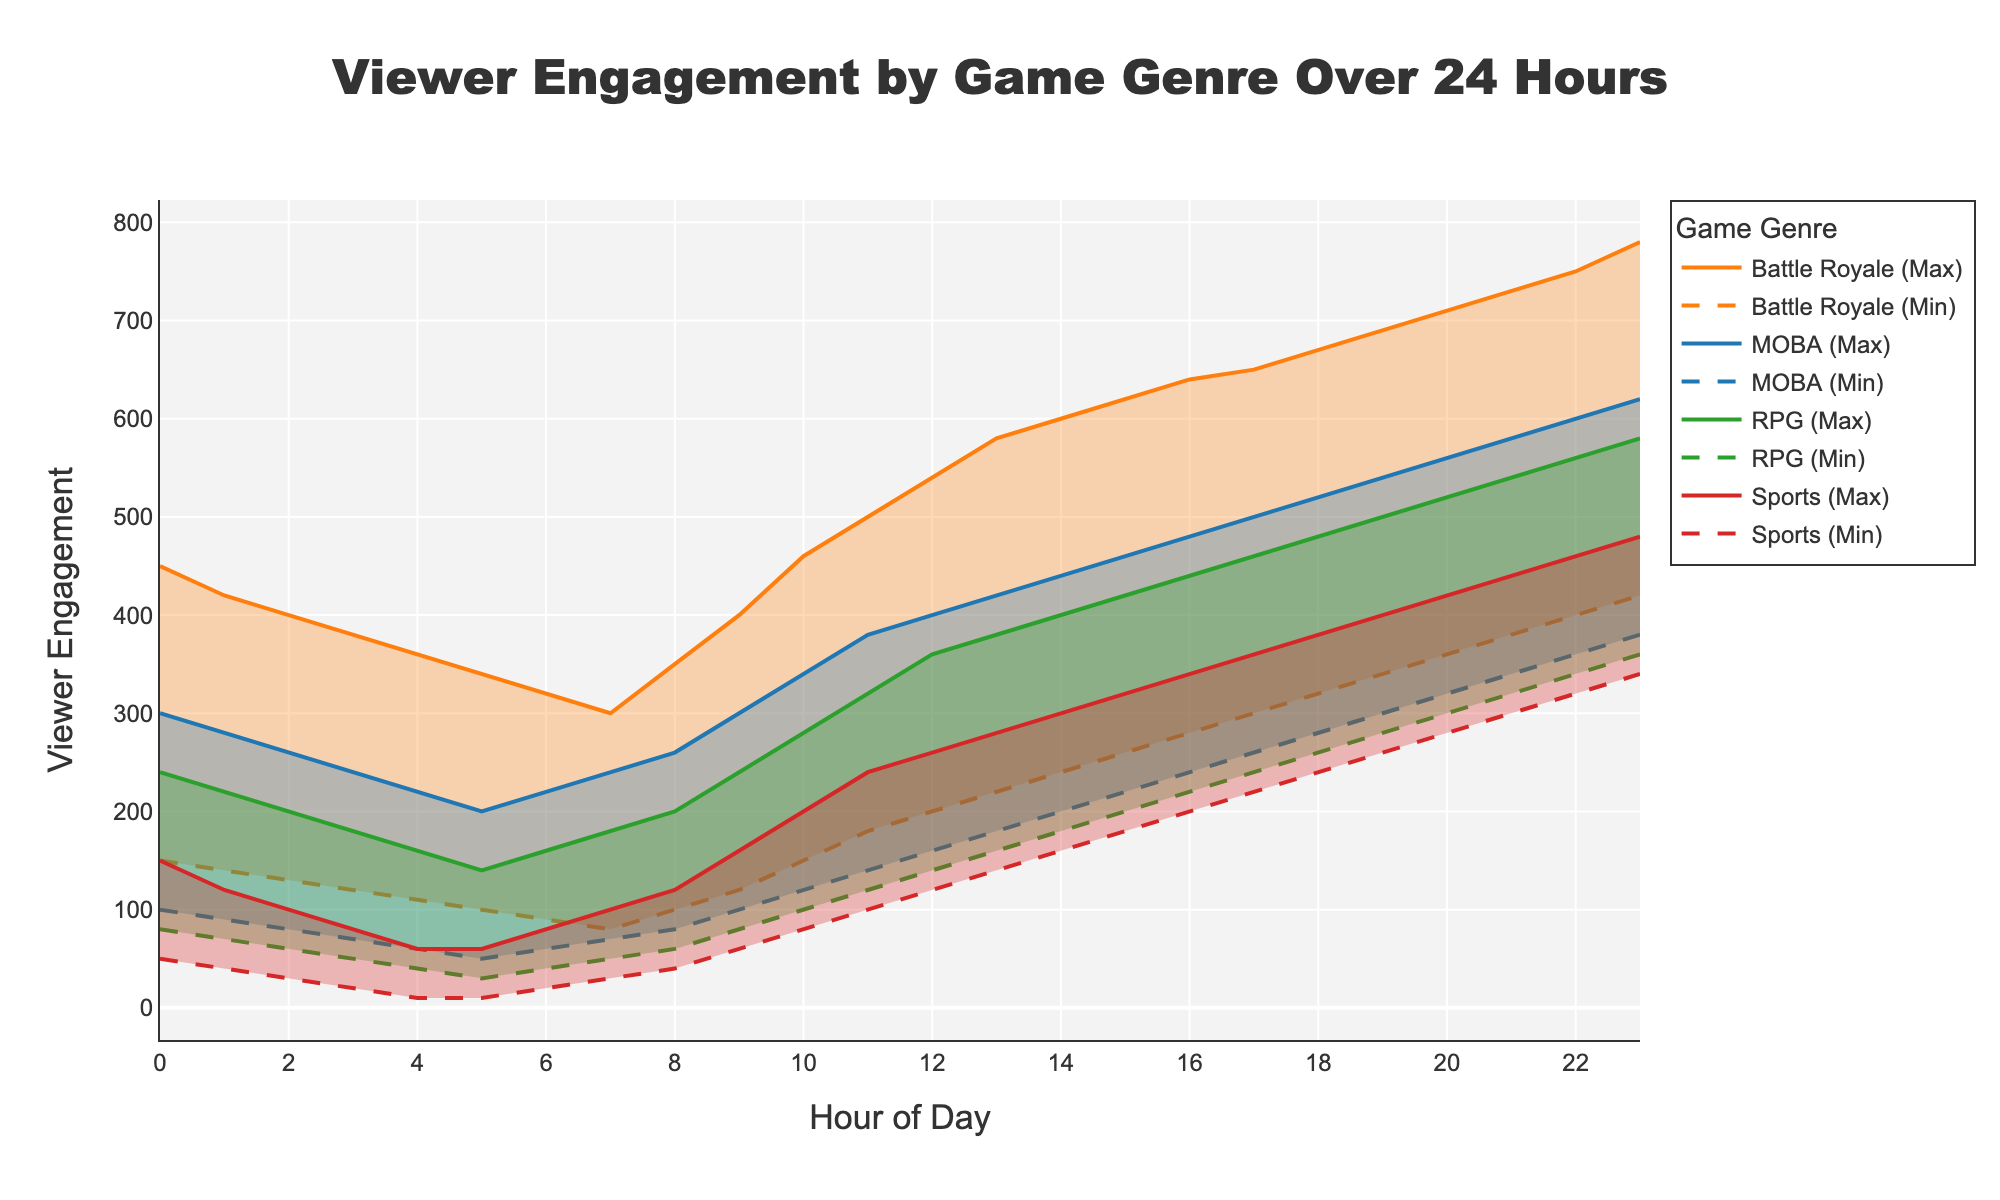Which game genre shows the highest peak viewer engagement throughout the day? By observing the maximum engagement line for each genre, the Battle Royale genre shows the highest peak viewer engagement. The highest peak for Battle Royale is 780 at 23 hours.
Answer: Battle Royale At what hour do RPG games reach their maximum engagement, and what is that engagement? The plot shows the maximum engagement line for RPG games. The peak is reached at 23 hours with a maximum engagement of 580.
Answer: 23 hours, 580 Compare the minimum engagement levels for Sports and MOBA genres at 10 hours. Which has a lower engagement? By examining the minimum engagement lines, at 10 hours, the minimum engagement for Sports is 80, whereas for MOBA it is 120. Therefore, Sports has a lower engagement.
Answer: Sports What is the average maximum engagement for MOBA games between 0 and 23 hours? First, find the sum of maximum engagements for MOBA from 0 to 23 hours: 300 + 280 + 260 + 240 + 220 + 200 + 220 + 240 + 260 + 300 + 340 + 380 + 400 + 420 + 440 + 460 + 480 + 500 + 520 + 540 + 560 + 580 + 600 + 620 = 8640. Divide the sum by the number of hours (24): 8640 / 24 = 360.
Answer: 360 During which hour is the gap between minimum and maximum engagement for Battle Royale games the widest, and what is that gap? The gap can be found by subtracting the minimum engagement from the maximum engagement for each hour. The widest gap is at 23 hours (780 - 420 = 360). This is the largest gap over all the hours.
Answer: 23 hours, 360 How does the viewer engagement of Sports games compare to RPG games at 18 hours? At 18 hours, observe the maximum and minimum engagement values for both genres. Sports have a range from 240 to 380, while RPG has 260 to 480. Sports viewer engagement is generally lower than RPG at 18 hours.
Answer: RPG higher What is the trend of viewer engagement for MOBA games from 0 to 5 hours? Look at the minimum and maximum engagement lines for MOBA games from 0 to 5 hours. Both lines show a decreasing trend, from 300 to 200 (maximum) and from 100 to 50 (minimum), indicating a drop in viewer engagement during these hours.
Answer: Decreasing Which genre shows the most stable minimum engagement throughout the day and what indicates this stability? Stability can be observed as minimal fluctuations in the minimum engagement line. MOBA games show the most stable minimum engagement with values ranging consistently from 50 to 380 throughout the day without significant variances.
Answer: MOBA What is the minimum engagement for Battle Royale games at the hour they have their peak maximum engagement? The peak maximum engagement for Battle Royale is at 23 hours, where the maximum is 780. At this hour, the minimum engagement for Battle Royale is 420.
Answer: 420 What is the difference in maximum viewer engagement between Battle Royale and Sports games at 20 hours? Observe the maximum engagement lines at 20 hours for both genres. Battle Royale has a maximum engagement of 710 and Sports has 420. The difference is 710 - 420 = 290.
Answer: 290 